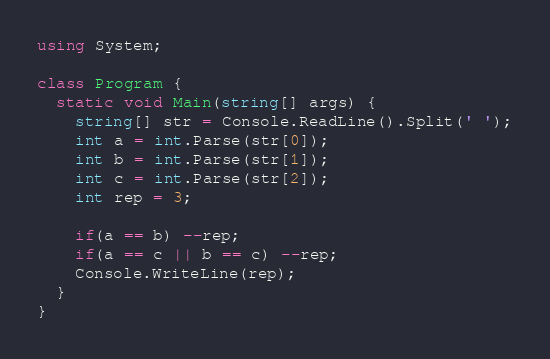<code> <loc_0><loc_0><loc_500><loc_500><_C#_>using System;

class Program {
  static void Main(string[] args) {
    string[] str = Console.ReadLine().Split(' ');
    int a = int.Parse(str[0]);
    int b = int.Parse(str[1]);
    int c = int.Parse(str[2]);
    int rep = 3;

    if(a == b) --rep;
    if(a == c || b == c) --rep;
    Console.WriteLine(rep);
  }
}
</code> 